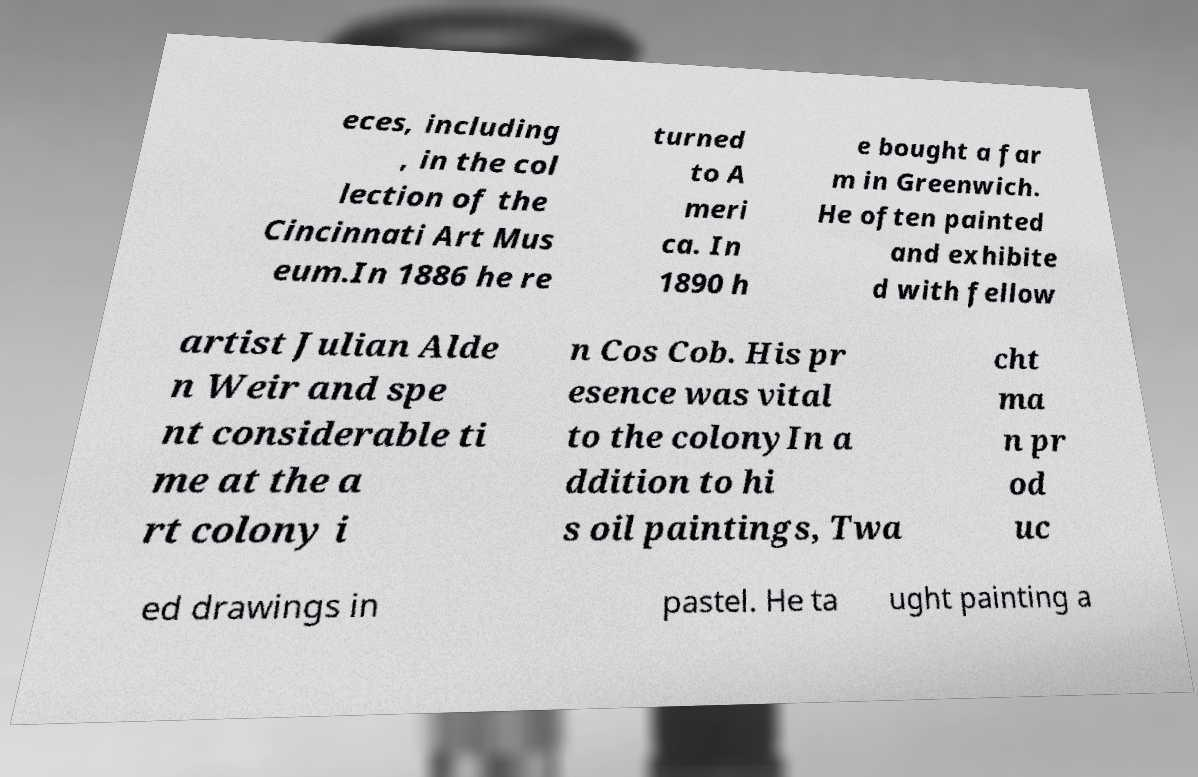I need the written content from this picture converted into text. Can you do that? eces, including , in the col lection of the Cincinnati Art Mus eum.In 1886 he re turned to A meri ca. In 1890 h e bought a far m in Greenwich. He often painted and exhibite d with fellow artist Julian Alde n Weir and spe nt considerable ti me at the a rt colony i n Cos Cob. His pr esence was vital to the colonyIn a ddition to hi s oil paintings, Twa cht ma n pr od uc ed drawings in pastel. He ta ught painting a 